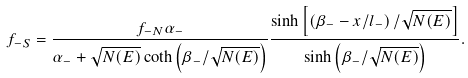<formula> <loc_0><loc_0><loc_500><loc_500>f _ { - S } = \frac { f _ { - N } \alpha _ { - } } { \alpha _ { - } + \sqrt { N ( E ) } \coth \left ( \beta _ { - } / \sqrt { N ( E ) } \right ) } \frac { \sinh \left [ \left ( \beta _ { - } - x / l _ { - } \right ) / \sqrt { N ( E ) } \right ] } { \sinh \left ( \beta _ { - } / \sqrt { N ( E ) } \right ) } .</formula> 